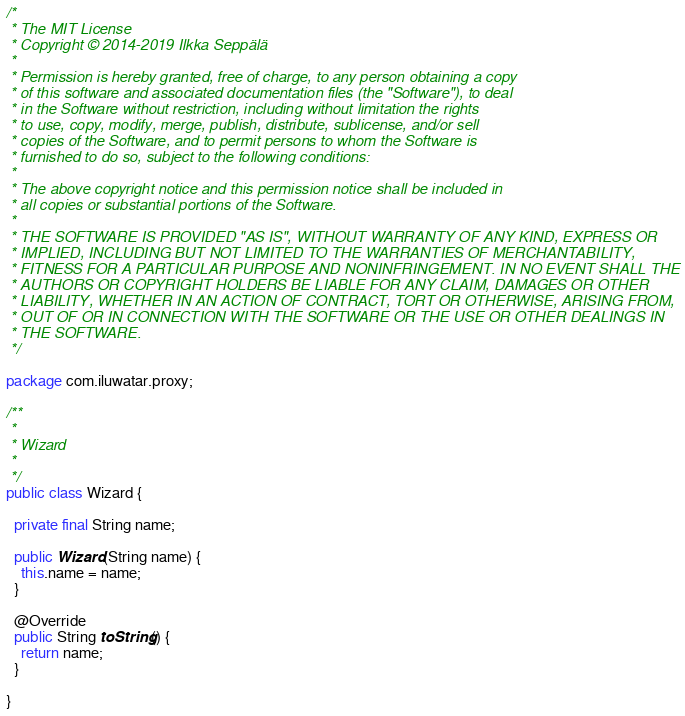<code> <loc_0><loc_0><loc_500><loc_500><_Java_>/*
 * The MIT License
 * Copyright © 2014-2019 Ilkka Seppälä
 *
 * Permission is hereby granted, free of charge, to any person obtaining a copy
 * of this software and associated documentation files (the "Software"), to deal
 * in the Software without restriction, including without limitation the rights
 * to use, copy, modify, merge, publish, distribute, sublicense, and/or sell
 * copies of the Software, and to permit persons to whom the Software is
 * furnished to do so, subject to the following conditions:
 *
 * The above copyright notice and this permission notice shall be included in
 * all copies or substantial portions of the Software.
 *
 * THE SOFTWARE IS PROVIDED "AS IS", WITHOUT WARRANTY OF ANY KIND, EXPRESS OR
 * IMPLIED, INCLUDING BUT NOT LIMITED TO THE WARRANTIES OF MERCHANTABILITY,
 * FITNESS FOR A PARTICULAR PURPOSE AND NONINFRINGEMENT. IN NO EVENT SHALL THE
 * AUTHORS OR COPYRIGHT HOLDERS BE LIABLE FOR ANY CLAIM, DAMAGES OR OTHER
 * LIABILITY, WHETHER IN AN ACTION OF CONTRACT, TORT OR OTHERWISE, ARISING FROM,
 * OUT OF OR IN CONNECTION WITH THE SOFTWARE OR THE USE OR OTHER DEALINGS IN
 * THE SOFTWARE.
 */

package com.iluwatar.proxy;

/**
 * 
 * Wizard
 *
 */
public class Wizard {

  private final String name;

  public Wizard(String name) {
    this.name = name;
  }

  @Override
  public String toString() {
    return name;
  }

}
</code> 